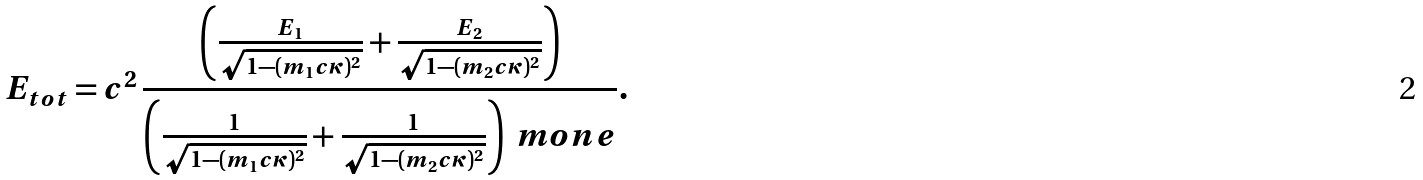<formula> <loc_0><loc_0><loc_500><loc_500>E _ { t o t } = c ^ { 2 } \, \frac { \left ( \frac { E _ { 1 } } { \sqrt { 1 - ( m _ { 1 } c \kappa ) ^ { 2 } } } + \frac { E _ { 2 } } { \sqrt { 1 - ( m _ { 2 } c \kappa ) ^ { 2 } } } \right ) } { \left ( \frac { 1 } { \sqrt { 1 - ( m _ { 1 } c \kappa ) ^ { 2 } } } + \frac { 1 } { \sqrt { 1 - ( m _ { 2 } c \kappa ) ^ { 2 } } } \right ) \ m o n e } .</formula> 